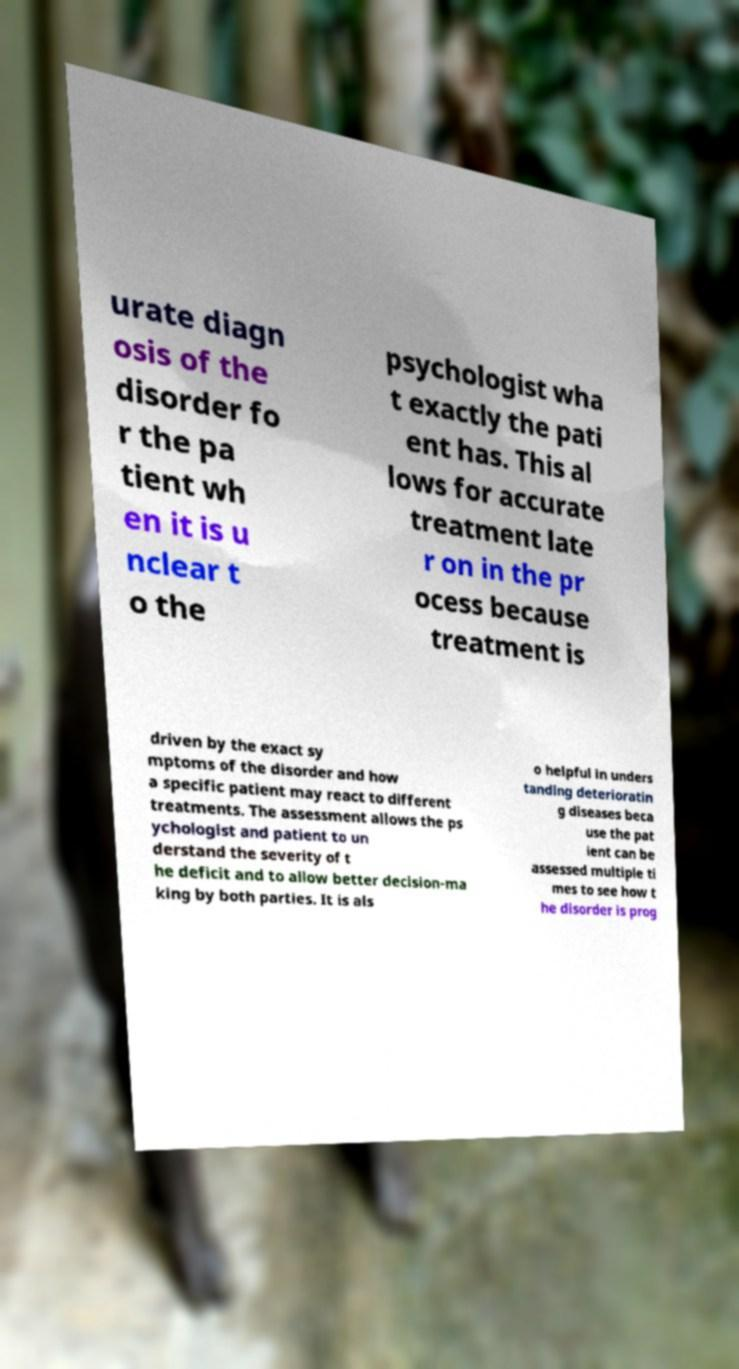There's text embedded in this image that I need extracted. Can you transcribe it verbatim? urate diagn osis of the disorder fo r the pa tient wh en it is u nclear t o the psychologist wha t exactly the pati ent has. This al lows for accurate treatment late r on in the pr ocess because treatment is driven by the exact sy mptoms of the disorder and how a specific patient may react to different treatments. The assessment allows the ps ychologist and patient to un derstand the severity of t he deficit and to allow better decision-ma king by both parties. It is als o helpful in unders tanding deterioratin g diseases beca use the pat ient can be assessed multiple ti mes to see how t he disorder is prog 